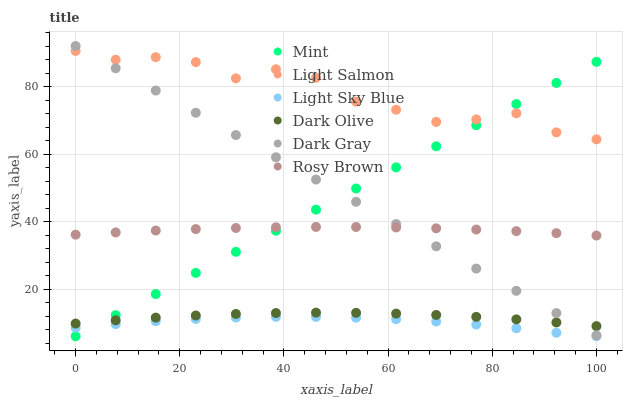Does Light Sky Blue have the minimum area under the curve?
Answer yes or no. Yes. Does Light Salmon have the maximum area under the curve?
Answer yes or no. Yes. Does Rosy Brown have the minimum area under the curve?
Answer yes or no. No. Does Rosy Brown have the maximum area under the curve?
Answer yes or no. No. Is Mint the smoothest?
Answer yes or no. Yes. Is Light Salmon the roughest?
Answer yes or no. Yes. Is Rosy Brown the smoothest?
Answer yes or no. No. Is Rosy Brown the roughest?
Answer yes or no. No. Does Light Sky Blue have the lowest value?
Answer yes or no. Yes. Does Rosy Brown have the lowest value?
Answer yes or no. No. Does Dark Gray have the highest value?
Answer yes or no. Yes. Does Rosy Brown have the highest value?
Answer yes or no. No. Is Light Sky Blue less than Dark Gray?
Answer yes or no. Yes. Is Dark Gray greater than Light Sky Blue?
Answer yes or no. Yes. Does Dark Olive intersect Dark Gray?
Answer yes or no. Yes. Is Dark Olive less than Dark Gray?
Answer yes or no. No. Is Dark Olive greater than Dark Gray?
Answer yes or no. No. Does Light Sky Blue intersect Dark Gray?
Answer yes or no. No. 